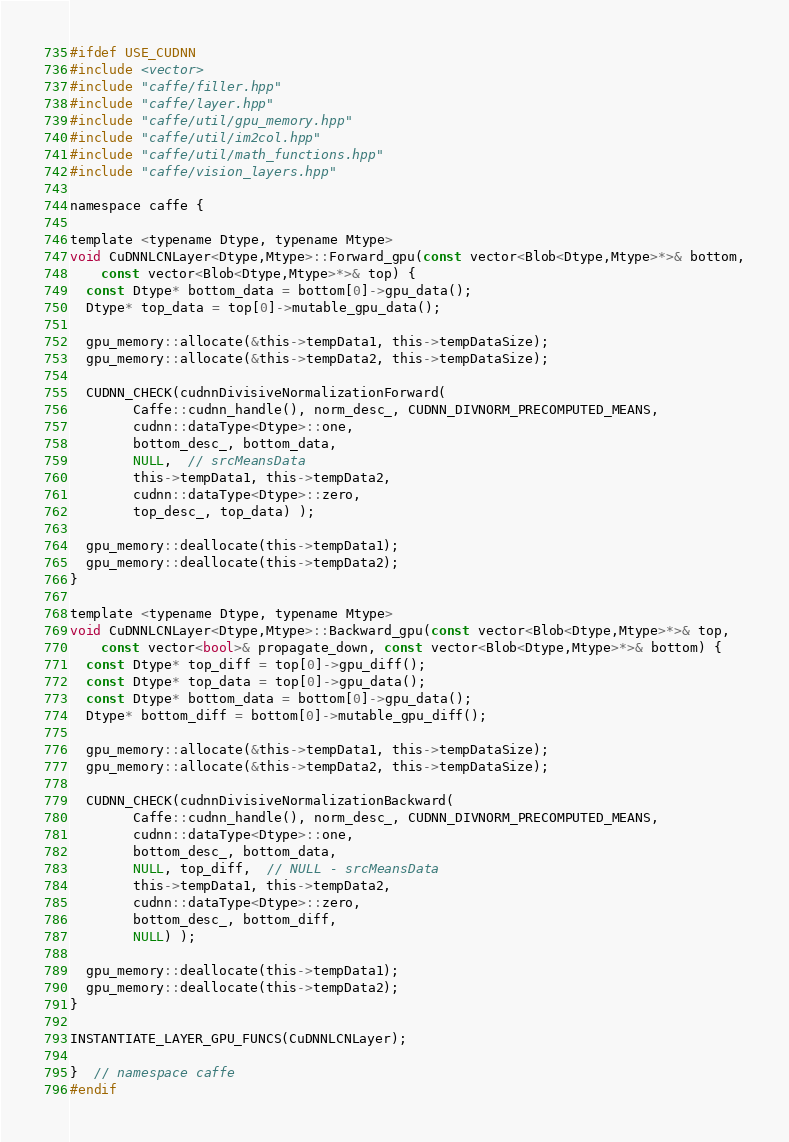<code> <loc_0><loc_0><loc_500><loc_500><_Cuda_>#ifdef USE_CUDNN
#include <vector>
#include "caffe/filler.hpp"
#include "caffe/layer.hpp"
#include "caffe/util/gpu_memory.hpp"
#include "caffe/util/im2col.hpp"
#include "caffe/util/math_functions.hpp"
#include "caffe/vision_layers.hpp"

namespace caffe {

template <typename Dtype, typename Mtype>
void CuDNNLCNLayer<Dtype,Mtype>::Forward_gpu(const vector<Blob<Dtype,Mtype>*>& bottom,
    const vector<Blob<Dtype,Mtype>*>& top) {
  const Dtype* bottom_data = bottom[0]->gpu_data();
  Dtype* top_data = top[0]->mutable_gpu_data();

  gpu_memory::allocate(&this->tempData1, this->tempDataSize);
  gpu_memory::allocate(&this->tempData2, this->tempDataSize);

  CUDNN_CHECK(cudnnDivisiveNormalizationForward(
        Caffe::cudnn_handle(), norm_desc_, CUDNN_DIVNORM_PRECOMPUTED_MEANS,
        cudnn::dataType<Dtype>::one,
        bottom_desc_, bottom_data,
        NULL,  // srcMeansData
        this->tempData1, this->tempData2,
        cudnn::dataType<Dtype>::zero,
        top_desc_, top_data) );

  gpu_memory::deallocate(this->tempData1);
  gpu_memory::deallocate(this->tempData2);
}

template <typename Dtype, typename Mtype>
void CuDNNLCNLayer<Dtype,Mtype>::Backward_gpu(const vector<Blob<Dtype,Mtype>*>& top,
    const vector<bool>& propagate_down, const vector<Blob<Dtype,Mtype>*>& bottom) {
  const Dtype* top_diff = top[0]->gpu_diff();
  const Dtype* top_data = top[0]->gpu_data();
  const Dtype* bottom_data = bottom[0]->gpu_data();
  Dtype* bottom_diff = bottom[0]->mutable_gpu_diff();

  gpu_memory::allocate(&this->tempData1, this->tempDataSize);
  gpu_memory::allocate(&this->tempData2, this->tempDataSize);

  CUDNN_CHECK(cudnnDivisiveNormalizationBackward(
        Caffe::cudnn_handle(), norm_desc_, CUDNN_DIVNORM_PRECOMPUTED_MEANS,
        cudnn::dataType<Dtype>::one,
        bottom_desc_, bottom_data,
        NULL, top_diff,  // NULL - srcMeansData
        this->tempData1, this->tempData2,
        cudnn::dataType<Dtype>::zero,
        bottom_desc_, bottom_diff,
        NULL) );

  gpu_memory::deallocate(this->tempData1);
  gpu_memory::deallocate(this->tempData2);
}

INSTANTIATE_LAYER_GPU_FUNCS(CuDNNLCNLayer);

}  // namespace caffe
#endif
</code> 